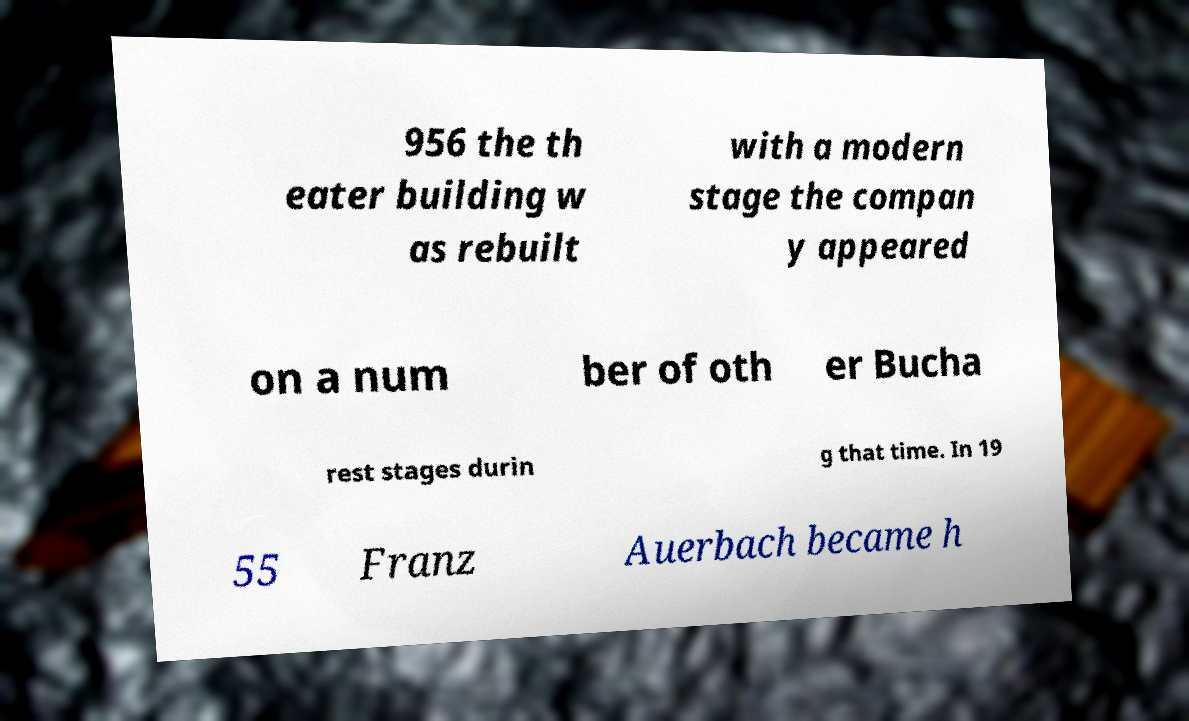For documentation purposes, I need the text within this image transcribed. Could you provide that? 956 the th eater building w as rebuilt with a modern stage the compan y appeared on a num ber of oth er Bucha rest stages durin g that time. In 19 55 Franz Auerbach became h 